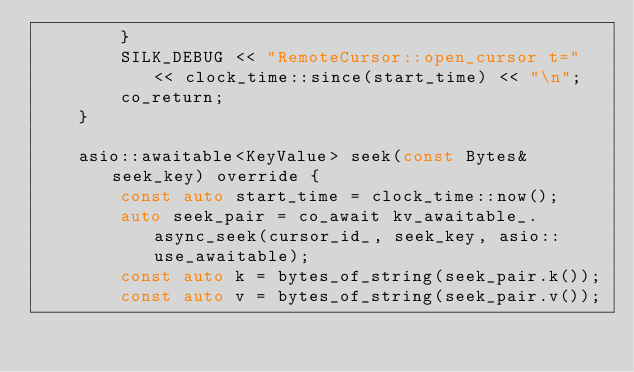<code> <loc_0><loc_0><loc_500><loc_500><_C++_>        }
        SILK_DEBUG << "RemoteCursor::open_cursor t=" << clock_time::since(start_time) << "\n";
        co_return;
    }

    asio::awaitable<KeyValue> seek(const Bytes& seek_key) override {
        const auto start_time = clock_time::now();
        auto seek_pair = co_await kv_awaitable_.async_seek(cursor_id_, seek_key, asio::use_awaitable);
        const auto k = bytes_of_string(seek_pair.k());
        const auto v = bytes_of_string(seek_pair.v());</code> 